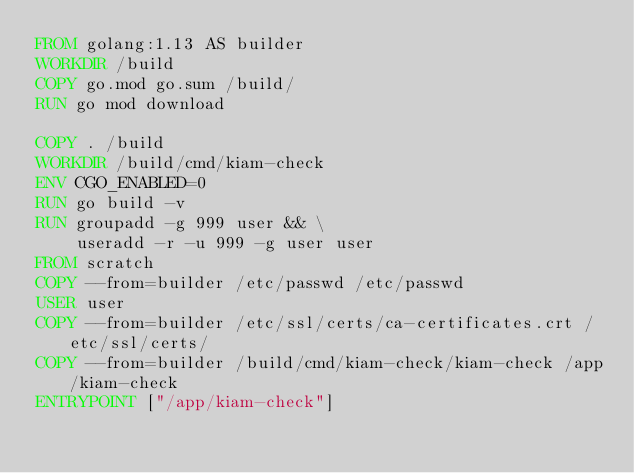Convert code to text. <code><loc_0><loc_0><loc_500><loc_500><_Dockerfile_>FROM golang:1.13 AS builder
WORKDIR /build
COPY go.mod go.sum /build/
RUN go mod download

COPY . /build
WORKDIR /build/cmd/kiam-check
ENV CGO_ENABLED=0
RUN go build -v
RUN groupadd -g 999 user && \
    useradd -r -u 999 -g user user
FROM scratch
COPY --from=builder /etc/passwd /etc/passwd
USER user
COPY --from=builder /etc/ssl/certs/ca-certificates.crt /etc/ssl/certs/
COPY --from=builder /build/cmd/kiam-check/kiam-check /app/kiam-check
ENTRYPOINT ["/app/kiam-check"]
</code> 